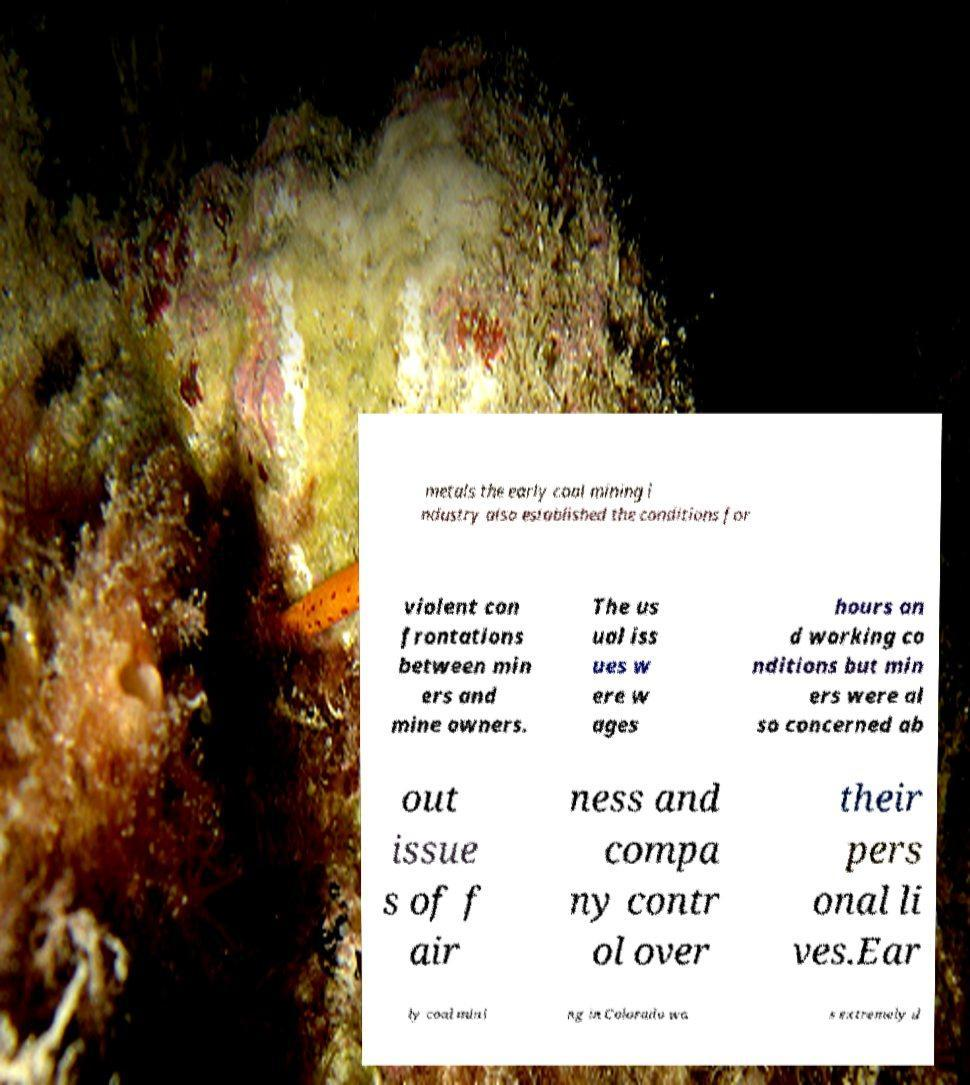Could you extract and type out the text from this image? metals the early coal mining i ndustry also established the conditions for violent con frontations between min ers and mine owners. The us ual iss ues w ere w ages hours an d working co nditions but min ers were al so concerned ab out issue s of f air ness and compa ny contr ol over their pers onal li ves.Ear ly coal mini ng in Colorado wa s extremely d 